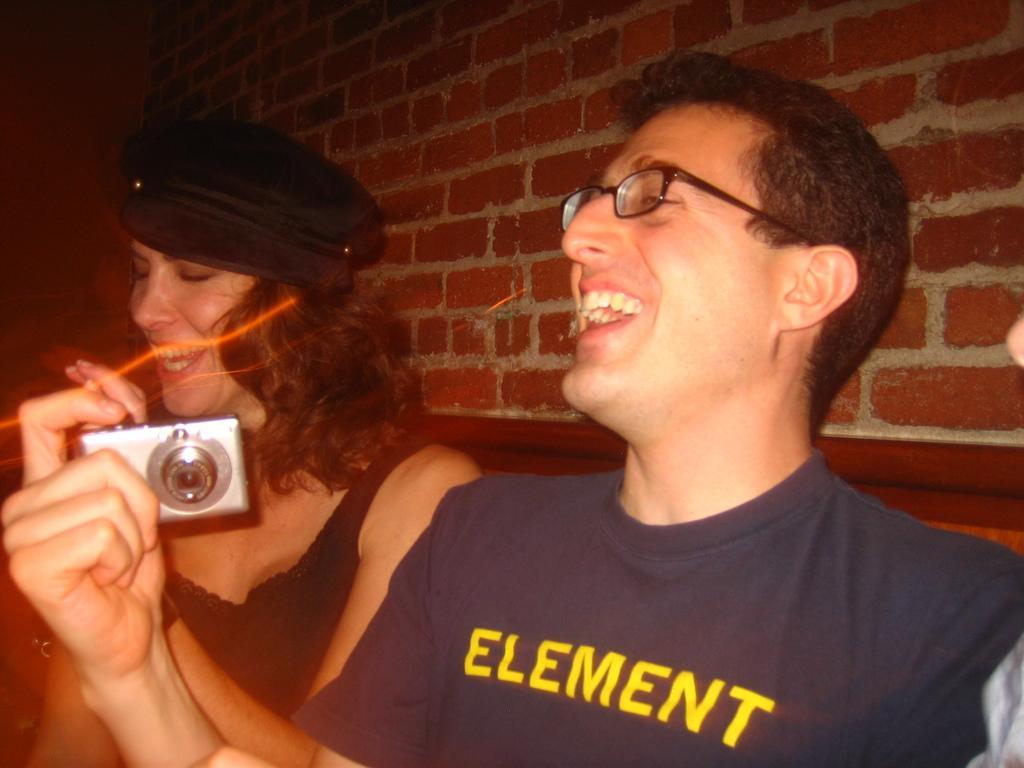In one or two sentences, can you explain what this image depicts? In this image i can see a man and the woman smiling,the man is holding a camera,the woman is having a cap at the back ground i can see a brick wall. 